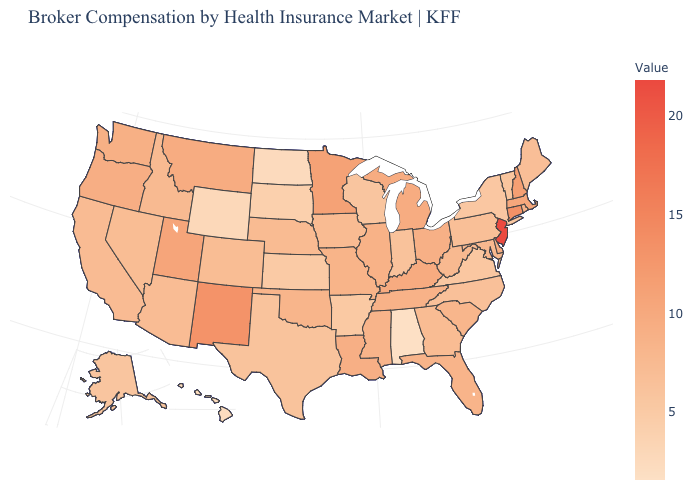Among the states that border Virginia , does North Carolina have the lowest value?
Keep it brief. Yes. Which states have the highest value in the USA?
Answer briefly. New Jersey. Does West Virginia have a higher value than Minnesota?
Be succinct. No. Which states have the highest value in the USA?
Be succinct. New Jersey. Among the states that border Maine , which have the highest value?
Answer briefly. New Hampshire. Does New Hampshire have the highest value in the Northeast?
Answer briefly. No. 